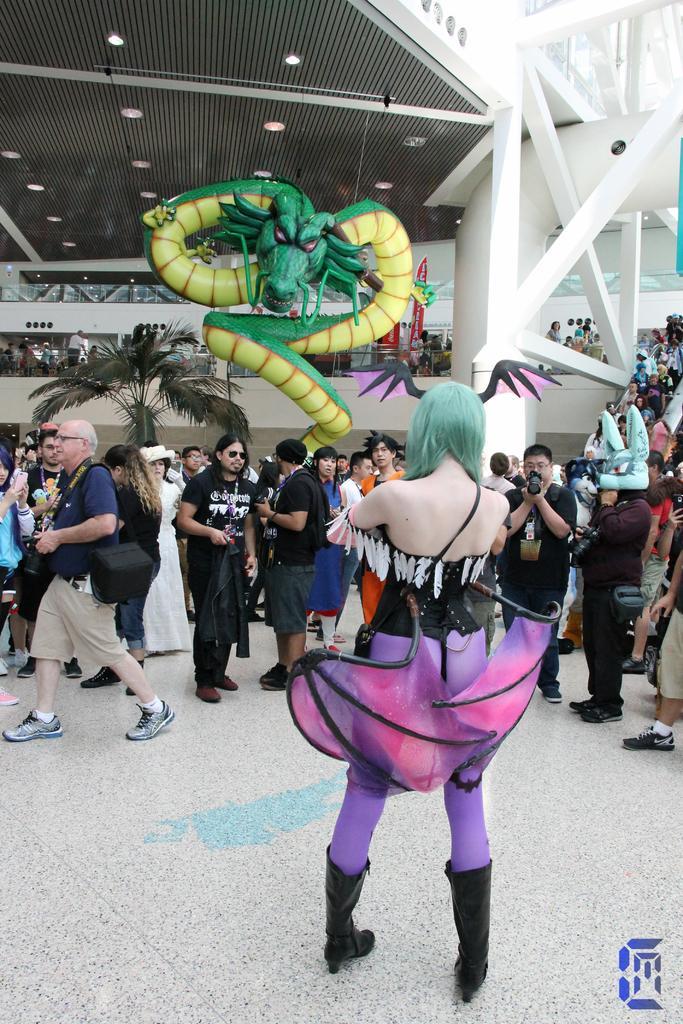Describe this image in one or two sentences. This picture describes about group of people, few are standing and few are walking, in the background we can see a inflatable dragon and a tree, and also we can find few buildings and lights. 